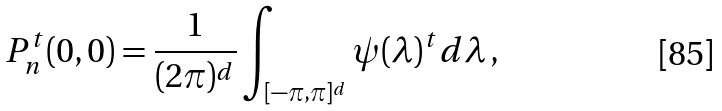Convert formula to latex. <formula><loc_0><loc_0><loc_500><loc_500>P _ { n } ^ { t } ( 0 , 0 ) = \frac { 1 } { ( 2 \pi ) ^ { d } } \int _ { [ - \pi , \pi ] ^ { d } } \psi ( \lambda ) ^ { t } d \lambda \, ,</formula> 